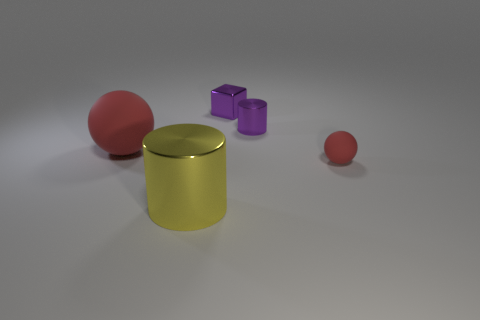Add 2 small rubber balls. How many objects exist? 7 Subtract all cubes. How many objects are left? 4 Subtract all large metal things. Subtract all metal objects. How many objects are left? 1 Add 5 small shiny cylinders. How many small shiny cylinders are left? 6 Add 4 large purple cylinders. How many large purple cylinders exist? 4 Subtract 0 brown balls. How many objects are left? 5 